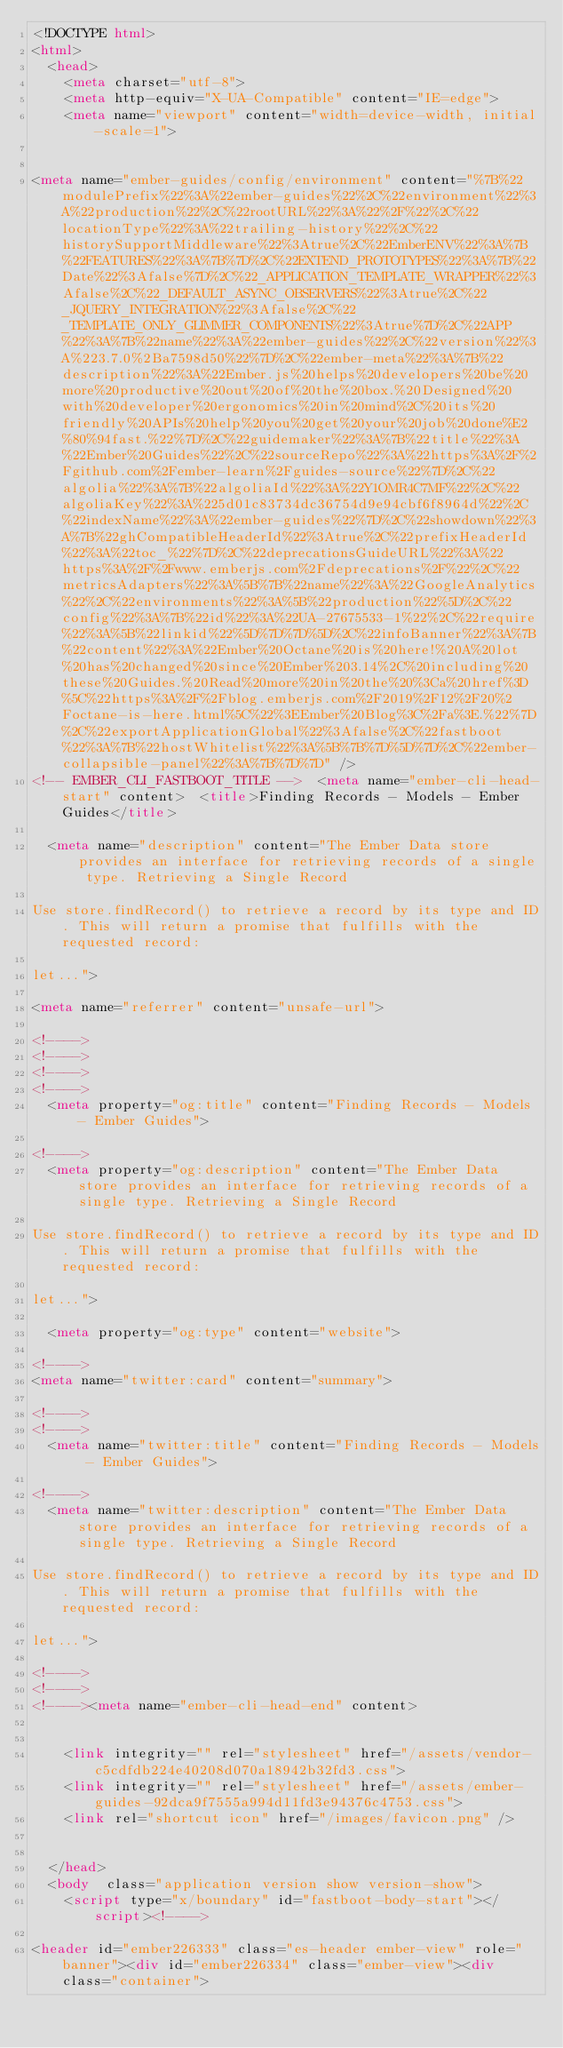<code> <loc_0><loc_0><loc_500><loc_500><_HTML_><!DOCTYPE html>
<html>
  <head>
    <meta charset="utf-8">
    <meta http-equiv="X-UA-Compatible" content="IE=edge">
    <meta name="viewport" content="width=device-width, initial-scale=1">

    
<meta name="ember-guides/config/environment" content="%7B%22modulePrefix%22%3A%22ember-guides%22%2C%22environment%22%3A%22production%22%2C%22rootURL%22%3A%22%2F%22%2C%22locationType%22%3A%22trailing-history%22%2C%22historySupportMiddleware%22%3Atrue%2C%22EmberENV%22%3A%7B%22FEATURES%22%3A%7B%7D%2C%22EXTEND_PROTOTYPES%22%3A%7B%22Date%22%3Afalse%7D%2C%22_APPLICATION_TEMPLATE_WRAPPER%22%3Afalse%2C%22_DEFAULT_ASYNC_OBSERVERS%22%3Atrue%2C%22_JQUERY_INTEGRATION%22%3Afalse%2C%22_TEMPLATE_ONLY_GLIMMER_COMPONENTS%22%3Atrue%7D%2C%22APP%22%3A%7B%22name%22%3A%22ember-guides%22%2C%22version%22%3A%223.7.0%2Ba7598d50%22%7D%2C%22ember-meta%22%3A%7B%22description%22%3A%22Ember.js%20helps%20developers%20be%20more%20productive%20out%20of%20the%20box.%20Designed%20with%20developer%20ergonomics%20in%20mind%2C%20its%20friendly%20APIs%20help%20you%20get%20your%20job%20done%E2%80%94fast.%22%7D%2C%22guidemaker%22%3A%7B%22title%22%3A%22Ember%20Guides%22%2C%22sourceRepo%22%3A%22https%3A%2F%2Fgithub.com%2Fember-learn%2Fguides-source%22%7D%2C%22algolia%22%3A%7B%22algoliaId%22%3A%22Y1OMR4C7MF%22%2C%22algoliaKey%22%3A%225d01c83734dc36754d9e94cbf6f8964d%22%2C%22indexName%22%3A%22ember-guides%22%7D%2C%22showdown%22%3A%7B%22ghCompatibleHeaderId%22%3Atrue%2C%22prefixHeaderId%22%3A%22toc_%22%7D%2C%22deprecationsGuideURL%22%3A%22https%3A%2F%2Fwww.emberjs.com%2Fdeprecations%2F%22%2C%22metricsAdapters%22%3A%5B%7B%22name%22%3A%22GoogleAnalytics%22%2C%22environments%22%3A%5B%22production%22%5D%2C%22config%22%3A%7B%22id%22%3A%22UA-27675533-1%22%2C%22require%22%3A%5B%22linkid%22%5D%7D%7D%5D%2C%22infoBanner%22%3A%7B%22content%22%3A%22Ember%20Octane%20is%20here!%20A%20lot%20has%20changed%20since%20Ember%203.14%2C%20including%20these%20Guides.%20Read%20more%20in%20the%20%3Ca%20href%3D%5C%22https%3A%2F%2Fblog.emberjs.com%2F2019%2F12%2F20%2Foctane-is-here.html%5C%22%3EEmber%20Blog%3C%2Fa%3E.%22%7D%2C%22exportApplicationGlobal%22%3Afalse%2C%22fastboot%22%3A%7B%22hostWhitelist%22%3A%5B%7B%7D%5D%7D%2C%22ember-collapsible-panel%22%3A%7B%7D%7D" />
<!-- EMBER_CLI_FASTBOOT_TITLE -->  <meta name="ember-cli-head-start" content>  <title>Finding Records - Models - Ember Guides</title>

  <meta name="description" content="The Ember Data store provides an interface for retrieving records of a single type. Retrieving a Single Record 

Use store.findRecord() to retrieve a record by its type and ID. This will return a promise that fulfills with the requested record: 

let...">

<meta name="referrer" content="unsafe-url">

<!---->
<!---->
<!---->
<!---->
  <meta property="og:title" content="Finding Records - Models - Ember Guides">

<!---->
  <meta property="og:description" content="The Ember Data store provides an interface for retrieving records of a single type. Retrieving a Single Record 

Use store.findRecord() to retrieve a record by its type and ID. This will return a promise that fulfills with the requested record: 

let...">

  <meta property="og:type" content="website">

<!---->
<meta name="twitter:card" content="summary">

<!---->
<!---->
  <meta name="twitter:title" content="Finding Records - Models - Ember Guides">

<!---->
  <meta name="twitter:description" content="The Ember Data store provides an interface for retrieving records of a single type. Retrieving a Single Record 

Use store.findRecord() to retrieve a record by its type and ID. This will return a promise that fulfills with the requested record: 

let...">

<!---->
<!---->
<!----><meta name="ember-cli-head-end" content>


    <link integrity="" rel="stylesheet" href="/assets/vendor-c5cdfdb224e40208d070a18942b32fd3.css">
    <link integrity="" rel="stylesheet" href="/assets/ember-guides-92dca9f7555a994d11fd3e94376c4753.css">
    <link rel="shortcut icon" href="/images/favicon.png" />

    
  </head>
  <body  class="application version show version-show">
    <script type="x/boundary" id="fastboot-body-start"></script><!---->

<header id="ember226333" class="es-header ember-view" role="banner"><div id="ember226334" class="ember-view"><div class="container"></code> 